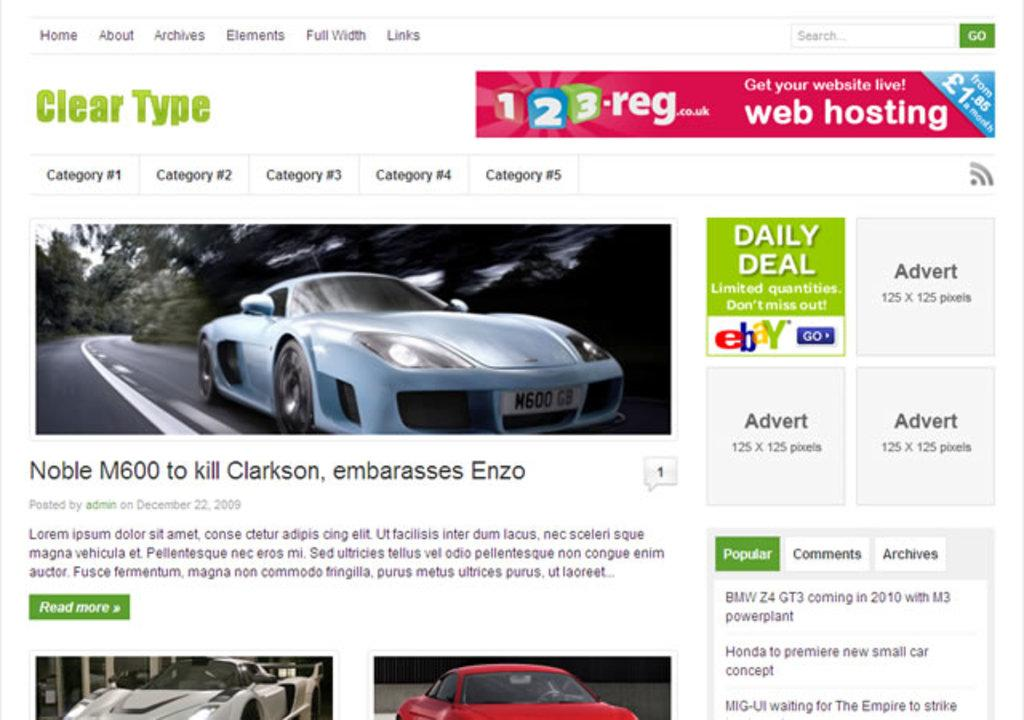What type of image is this? The image is a website or a screenshot of a desktop. What can be found on the image? There is text and cars in the image. Are there any numerical elements in the image? Yes, there are numbers in the image. How many stars are visible in the image? There are no stars present in the image. What is the size of the planes in the image? There are no planes present in the image. 